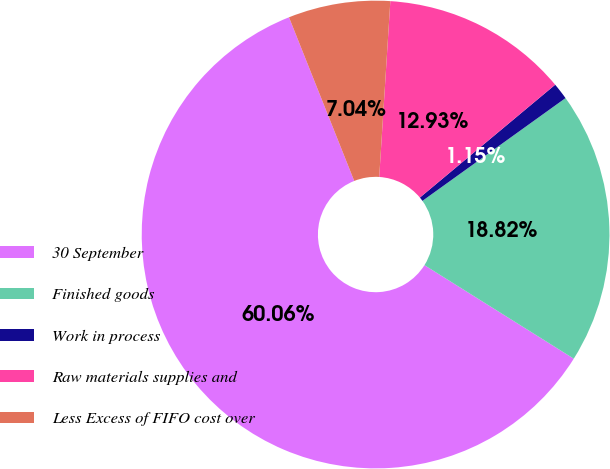Convert chart to OTSL. <chart><loc_0><loc_0><loc_500><loc_500><pie_chart><fcel>30 September<fcel>Finished goods<fcel>Work in process<fcel>Raw materials supplies and<fcel>Less Excess of FIFO cost over<nl><fcel>60.05%<fcel>18.82%<fcel>1.15%<fcel>12.93%<fcel>7.04%<nl></chart> 